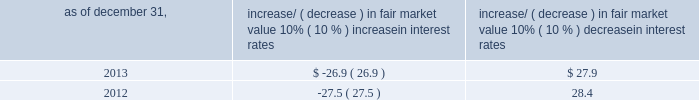Item 7a .
Quantitative and qualitative disclosures about market risk ( amounts in millions ) in the normal course of business , we are exposed to market risks related to interest rates , foreign currency rates and certain balance sheet items .
From time to time , we use derivative instruments , pursuant to established guidelines and policies , to manage some portion of these risks .
Derivative instruments utilized in our hedging activities are viewed as risk management tools and are not used for trading or speculative purposes .
Interest rates our exposure to market risk for changes in interest rates relates primarily to the fair market value and cash flows of our debt obligations .
The majority of our debt ( approximately 89% ( 89 % ) and 93% ( 93 % ) as of december 31 , 2013 and 2012 , respectively ) bears interest at fixed rates .
We do have debt with variable interest rates , but a 10% ( 10 % ) increase or decrease in interest rates would not be material to our interest expense or cash flows .
The fair market value of our debt is sensitive to changes in interest rates , and the impact of a 10% ( 10 % ) change in interest rates is summarized below .
Increase/ ( decrease ) in fair market value as of december 31 , 10% ( 10 % ) increase in interest rates 10% ( 10 % ) decrease in interest rates .
We have used interest rate swaps for risk management purposes to manage our exposure to changes in interest rates .
We do not have any interest rate swaps outstanding as of december 31 , 2013 .
We had $ 1642.1 of cash , cash equivalents and marketable securities as of december 31 , 2013 that we generally invest in conservative , short-term bank deposits or securities .
The interest income generated from these investments is subject to both domestic and foreign interest rate movements .
During 2013 and 2012 , we had interest income of $ 24.7 and $ 29.5 , respectively .
Based on our 2013 results , a 100-basis-point increase or decrease in interest rates would affect our interest income by approximately $ 16.4 , assuming that all cash , cash equivalents and marketable securities are impacted in the same manner and balances remain constant from year-end 2013 levels .
Foreign currency rates we are subject to translation and transaction risks related to changes in foreign currency exchange rates .
Since we report revenues and expenses in u.s .
Dollars , changes in exchange rates may either positively or negatively affect our consolidated revenues and expenses ( as expressed in u.s .
Dollars ) from foreign operations .
The primary foreign currencies that impacted our results during 2013 were the australian dollar , brazilian real , euro , japanese yen and the south african rand .
Based on 2013 exchange rates and operating results , if the u.s .
Dollar were to strengthen or weaken by 10% ( 10 % ) , we currently estimate operating income would decrease or increase between 3% ( 3 % ) and 4% ( 4 % ) , assuming that all currencies are impacted in the same manner and our international revenue and expenses remain constant at 2013 levels .
The functional currency of our foreign operations is generally their respective local currency .
Assets and liabilities are translated at the exchange rates in effect at the balance sheet date , and revenues and expenses are translated at the average exchange rates during the period presented .
The resulting translation adjustments are recorded as a component of accumulated other comprehensive loss , net of tax , in the stockholders 2019 equity section of our consolidated balance sheets .
Our foreign subsidiaries generally collect revenues and pay expenses in their functional currency , mitigating transaction risk .
However , certain subsidiaries may enter into transactions in currencies other than their functional currency .
Assets and liabilities denominated in currencies other than the functional currency are susceptible to movements in foreign currency until final settlement .
Currency transaction gains or losses primarily arising from transactions in currencies other than the functional currency are included in office and general expenses .
We have not entered into a material amount of foreign currency forward exchange contracts or other derivative financial instruments to hedge the effects of potential adverse fluctuations in foreign currency exchange rates. .
In 2013 what was the net amount that was received from increasing and decreasing interest rates , including interest income? 
Rationale: the table gave the increase and decrease of interest and line 14 gives the interest income . to find the net total you need to subtract the decrease from the increase and then added the interest income .
Computations: (24.7 + (27.9 - 26.9))
Answer: 25.7. 